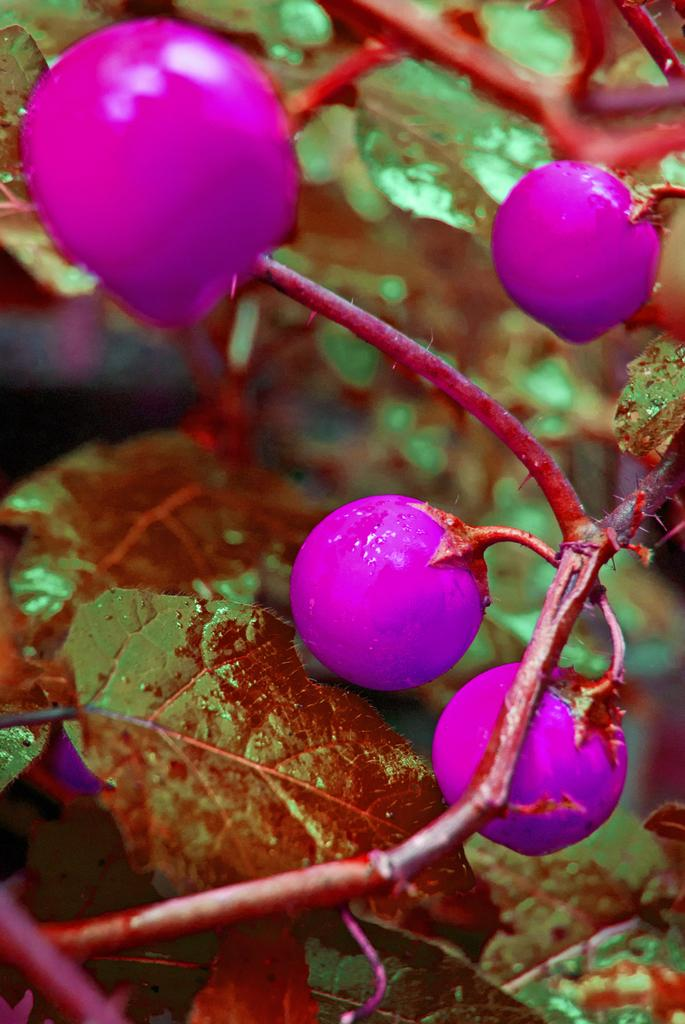What is depicted on the branches in the image? There are fruits on the branches in the image. What else can be seen on the branches besides the fruits? There are leaves on the branches. Can you describe the background of the image? The background of the image is blurry. What type of motion can be seen in the image? There is no motion depicted in the image; it is a still image of branches with fruits and leaves. What season is represented by the image? The image does not explicitly represent a specific season, as it only shows branches with fruits and leaves. 